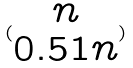<formula> <loc_0><loc_0><loc_500><loc_500>( \begin{matrix} n \\ 0 . 5 1 n \end{matrix} )</formula> 